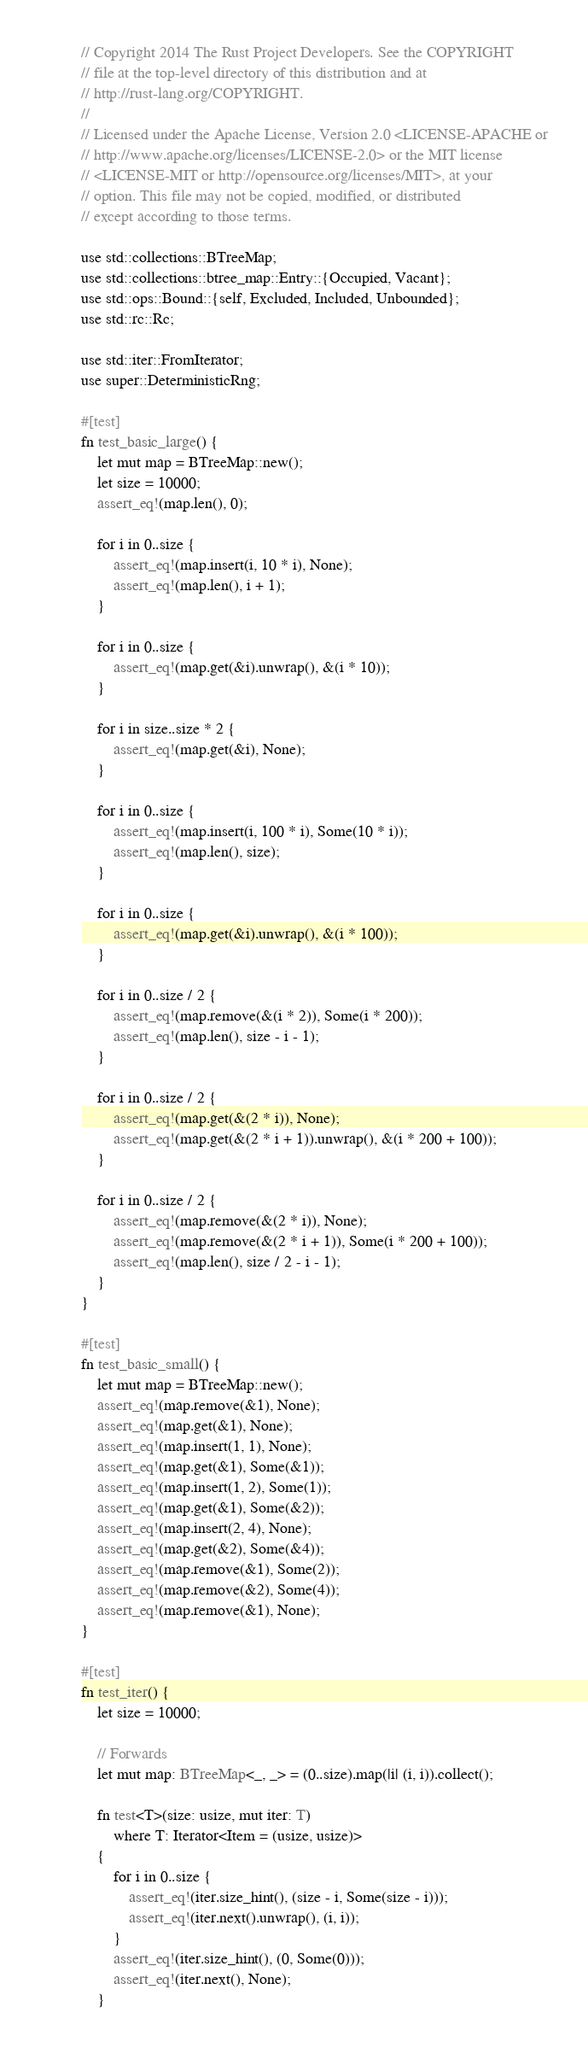<code> <loc_0><loc_0><loc_500><loc_500><_Rust_>// Copyright 2014 The Rust Project Developers. See the COPYRIGHT
// file at the top-level directory of this distribution and at
// http://rust-lang.org/COPYRIGHT.
//
// Licensed under the Apache License, Version 2.0 <LICENSE-APACHE or
// http://www.apache.org/licenses/LICENSE-2.0> or the MIT license
// <LICENSE-MIT or http://opensource.org/licenses/MIT>, at your
// option. This file may not be copied, modified, or distributed
// except according to those terms.

use std::collections::BTreeMap;
use std::collections::btree_map::Entry::{Occupied, Vacant};
use std::ops::Bound::{self, Excluded, Included, Unbounded};
use std::rc::Rc;

use std::iter::FromIterator;
use super::DeterministicRng;

#[test]
fn test_basic_large() {
    let mut map = BTreeMap::new();
    let size = 10000;
    assert_eq!(map.len(), 0);

    for i in 0..size {
        assert_eq!(map.insert(i, 10 * i), None);
        assert_eq!(map.len(), i + 1);
    }

    for i in 0..size {
        assert_eq!(map.get(&i).unwrap(), &(i * 10));
    }

    for i in size..size * 2 {
        assert_eq!(map.get(&i), None);
    }

    for i in 0..size {
        assert_eq!(map.insert(i, 100 * i), Some(10 * i));
        assert_eq!(map.len(), size);
    }

    for i in 0..size {
        assert_eq!(map.get(&i).unwrap(), &(i * 100));
    }

    for i in 0..size / 2 {
        assert_eq!(map.remove(&(i * 2)), Some(i * 200));
        assert_eq!(map.len(), size - i - 1);
    }

    for i in 0..size / 2 {
        assert_eq!(map.get(&(2 * i)), None);
        assert_eq!(map.get(&(2 * i + 1)).unwrap(), &(i * 200 + 100));
    }

    for i in 0..size / 2 {
        assert_eq!(map.remove(&(2 * i)), None);
        assert_eq!(map.remove(&(2 * i + 1)), Some(i * 200 + 100));
        assert_eq!(map.len(), size / 2 - i - 1);
    }
}

#[test]
fn test_basic_small() {
    let mut map = BTreeMap::new();
    assert_eq!(map.remove(&1), None);
    assert_eq!(map.get(&1), None);
    assert_eq!(map.insert(1, 1), None);
    assert_eq!(map.get(&1), Some(&1));
    assert_eq!(map.insert(1, 2), Some(1));
    assert_eq!(map.get(&1), Some(&2));
    assert_eq!(map.insert(2, 4), None);
    assert_eq!(map.get(&2), Some(&4));
    assert_eq!(map.remove(&1), Some(2));
    assert_eq!(map.remove(&2), Some(4));
    assert_eq!(map.remove(&1), None);
}

#[test]
fn test_iter() {
    let size = 10000;

    // Forwards
    let mut map: BTreeMap<_, _> = (0..size).map(|i| (i, i)).collect();

    fn test<T>(size: usize, mut iter: T)
        where T: Iterator<Item = (usize, usize)>
    {
        for i in 0..size {
            assert_eq!(iter.size_hint(), (size - i, Some(size - i)));
            assert_eq!(iter.next().unwrap(), (i, i));
        }
        assert_eq!(iter.size_hint(), (0, Some(0)));
        assert_eq!(iter.next(), None);
    }</code> 